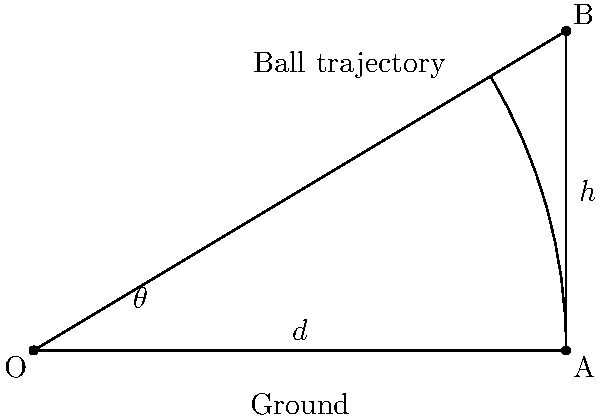In a crucial match at the Mandela National Stadium in Kampala, a Ugandan batsman wants to hit a six. The boundary is 60 meters away, and the optimal height for clearing the boundary is 15 meters. What is the optimal angle $\theta$ (in degrees) at which the batsman should hit the ball to achieve this six? Let's approach this step-by-step:

1) In the diagram, OA represents the ground distance to the boundary (d = 60 m), and AB represents the optimal height (h = 15 m).

2) We need to find the angle $\theta$ that forms this optimal trajectory.

3) We can use the tangent function to relate the angle to the height and distance:

   $\tan(\theta) = \frac{\text{opposite}}{\text{adjacent}} = \frac{h}{d} = \frac{15}{60}$

4) Simplify the fraction:
   
   $\tan(\theta) = \frac{1}{4}$

5) To find $\theta$, we need to take the inverse tangent (arctan or $\tan^{-1}$):

   $\theta = \tan^{-1}(\frac{1}{4})$

6) Using a calculator or trigonometric tables:

   $\theta \approx 14.0362^\circ$

7) Rounding to the nearest degree:

   $\theta \approx 14^\circ$

This angle provides the optimal trajectory for the ball to clear the boundary with the given height and distance constraints.
Answer: $14^\circ$ 